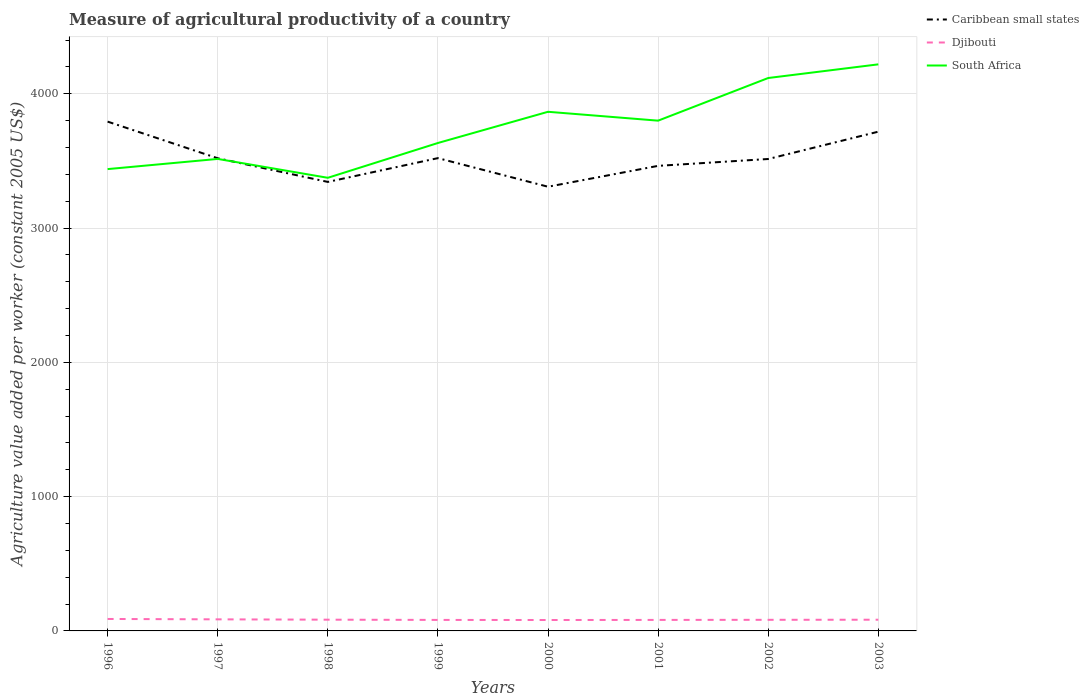How many different coloured lines are there?
Your answer should be compact. 3. Does the line corresponding to Caribbean small states intersect with the line corresponding to South Africa?
Your response must be concise. Yes. Is the number of lines equal to the number of legend labels?
Make the answer very short. Yes. Across all years, what is the maximum measure of agricultural productivity in Caribbean small states?
Ensure brevity in your answer.  3307.74. In which year was the measure of agricultural productivity in Caribbean small states maximum?
Your answer should be very brief. 2000. What is the total measure of agricultural productivity in Djibouti in the graph?
Give a very brief answer. 0.63. What is the difference between the highest and the second highest measure of agricultural productivity in Djibouti?
Your answer should be very brief. 7.74. What is the difference between the highest and the lowest measure of agricultural productivity in South Africa?
Provide a succinct answer. 4. How many lines are there?
Make the answer very short. 3. How many years are there in the graph?
Provide a succinct answer. 8. What is the difference between two consecutive major ticks on the Y-axis?
Provide a succinct answer. 1000. Are the values on the major ticks of Y-axis written in scientific E-notation?
Offer a terse response. No. Where does the legend appear in the graph?
Offer a very short reply. Top right. How many legend labels are there?
Offer a terse response. 3. What is the title of the graph?
Your answer should be compact. Measure of agricultural productivity of a country. Does "Burundi" appear as one of the legend labels in the graph?
Your response must be concise. No. What is the label or title of the X-axis?
Give a very brief answer. Years. What is the label or title of the Y-axis?
Provide a short and direct response. Agriculture value added per worker (constant 2005 US$). What is the Agriculture value added per worker (constant 2005 US$) in Caribbean small states in 1996?
Provide a short and direct response. 3792.64. What is the Agriculture value added per worker (constant 2005 US$) in Djibouti in 1996?
Provide a short and direct response. 89.04. What is the Agriculture value added per worker (constant 2005 US$) of South Africa in 1996?
Your answer should be compact. 3438.99. What is the Agriculture value added per worker (constant 2005 US$) in Caribbean small states in 1997?
Keep it short and to the point. 3519.77. What is the Agriculture value added per worker (constant 2005 US$) in Djibouti in 1997?
Keep it short and to the point. 86.22. What is the Agriculture value added per worker (constant 2005 US$) of South Africa in 1997?
Keep it short and to the point. 3514.77. What is the Agriculture value added per worker (constant 2005 US$) in Caribbean small states in 1998?
Provide a short and direct response. 3343.62. What is the Agriculture value added per worker (constant 2005 US$) of Djibouti in 1998?
Offer a very short reply. 83.72. What is the Agriculture value added per worker (constant 2005 US$) of South Africa in 1998?
Give a very brief answer. 3374.27. What is the Agriculture value added per worker (constant 2005 US$) of Caribbean small states in 1999?
Provide a succinct answer. 3520.71. What is the Agriculture value added per worker (constant 2005 US$) in Djibouti in 1999?
Keep it short and to the point. 81.93. What is the Agriculture value added per worker (constant 2005 US$) in South Africa in 1999?
Offer a very short reply. 3633.44. What is the Agriculture value added per worker (constant 2005 US$) in Caribbean small states in 2000?
Give a very brief answer. 3307.74. What is the Agriculture value added per worker (constant 2005 US$) of Djibouti in 2000?
Provide a succinct answer. 81.3. What is the Agriculture value added per worker (constant 2005 US$) in South Africa in 2000?
Your answer should be very brief. 3865.82. What is the Agriculture value added per worker (constant 2005 US$) of Caribbean small states in 2001?
Your response must be concise. 3463.22. What is the Agriculture value added per worker (constant 2005 US$) in Djibouti in 2001?
Offer a very short reply. 81.98. What is the Agriculture value added per worker (constant 2005 US$) in South Africa in 2001?
Your answer should be compact. 3799.78. What is the Agriculture value added per worker (constant 2005 US$) in Caribbean small states in 2002?
Ensure brevity in your answer.  3514.27. What is the Agriculture value added per worker (constant 2005 US$) in Djibouti in 2002?
Ensure brevity in your answer.  82.7. What is the Agriculture value added per worker (constant 2005 US$) of South Africa in 2002?
Your answer should be compact. 4117.37. What is the Agriculture value added per worker (constant 2005 US$) in Caribbean small states in 2003?
Ensure brevity in your answer.  3717.71. What is the Agriculture value added per worker (constant 2005 US$) of Djibouti in 2003?
Make the answer very short. 83.47. What is the Agriculture value added per worker (constant 2005 US$) of South Africa in 2003?
Make the answer very short. 4219.01. Across all years, what is the maximum Agriculture value added per worker (constant 2005 US$) of Caribbean small states?
Your response must be concise. 3792.64. Across all years, what is the maximum Agriculture value added per worker (constant 2005 US$) in Djibouti?
Keep it short and to the point. 89.04. Across all years, what is the maximum Agriculture value added per worker (constant 2005 US$) of South Africa?
Keep it short and to the point. 4219.01. Across all years, what is the minimum Agriculture value added per worker (constant 2005 US$) in Caribbean small states?
Provide a succinct answer. 3307.74. Across all years, what is the minimum Agriculture value added per worker (constant 2005 US$) in Djibouti?
Offer a very short reply. 81.3. Across all years, what is the minimum Agriculture value added per worker (constant 2005 US$) of South Africa?
Offer a terse response. 3374.27. What is the total Agriculture value added per worker (constant 2005 US$) of Caribbean small states in the graph?
Make the answer very short. 2.82e+04. What is the total Agriculture value added per worker (constant 2005 US$) of Djibouti in the graph?
Keep it short and to the point. 670.37. What is the total Agriculture value added per worker (constant 2005 US$) of South Africa in the graph?
Your answer should be compact. 3.00e+04. What is the difference between the Agriculture value added per worker (constant 2005 US$) in Caribbean small states in 1996 and that in 1997?
Ensure brevity in your answer.  272.87. What is the difference between the Agriculture value added per worker (constant 2005 US$) in Djibouti in 1996 and that in 1997?
Keep it short and to the point. 2.82. What is the difference between the Agriculture value added per worker (constant 2005 US$) in South Africa in 1996 and that in 1997?
Your answer should be very brief. -75.78. What is the difference between the Agriculture value added per worker (constant 2005 US$) in Caribbean small states in 1996 and that in 1998?
Your answer should be very brief. 449.02. What is the difference between the Agriculture value added per worker (constant 2005 US$) in Djibouti in 1996 and that in 1998?
Give a very brief answer. 5.32. What is the difference between the Agriculture value added per worker (constant 2005 US$) in South Africa in 1996 and that in 1998?
Offer a terse response. 64.73. What is the difference between the Agriculture value added per worker (constant 2005 US$) in Caribbean small states in 1996 and that in 1999?
Provide a short and direct response. 271.93. What is the difference between the Agriculture value added per worker (constant 2005 US$) in Djibouti in 1996 and that in 1999?
Your answer should be very brief. 7.11. What is the difference between the Agriculture value added per worker (constant 2005 US$) in South Africa in 1996 and that in 1999?
Offer a terse response. -194.45. What is the difference between the Agriculture value added per worker (constant 2005 US$) of Caribbean small states in 1996 and that in 2000?
Your answer should be compact. 484.9. What is the difference between the Agriculture value added per worker (constant 2005 US$) of Djibouti in 1996 and that in 2000?
Ensure brevity in your answer.  7.74. What is the difference between the Agriculture value added per worker (constant 2005 US$) of South Africa in 1996 and that in 2000?
Give a very brief answer. -426.83. What is the difference between the Agriculture value added per worker (constant 2005 US$) of Caribbean small states in 1996 and that in 2001?
Make the answer very short. 329.43. What is the difference between the Agriculture value added per worker (constant 2005 US$) of Djibouti in 1996 and that in 2001?
Offer a very short reply. 7.06. What is the difference between the Agriculture value added per worker (constant 2005 US$) of South Africa in 1996 and that in 2001?
Provide a short and direct response. -360.79. What is the difference between the Agriculture value added per worker (constant 2005 US$) in Caribbean small states in 1996 and that in 2002?
Your answer should be very brief. 278.37. What is the difference between the Agriculture value added per worker (constant 2005 US$) of Djibouti in 1996 and that in 2002?
Provide a short and direct response. 6.33. What is the difference between the Agriculture value added per worker (constant 2005 US$) in South Africa in 1996 and that in 2002?
Offer a very short reply. -678.37. What is the difference between the Agriculture value added per worker (constant 2005 US$) of Caribbean small states in 1996 and that in 2003?
Your answer should be very brief. 74.93. What is the difference between the Agriculture value added per worker (constant 2005 US$) of Djibouti in 1996 and that in 2003?
Keep it short and to the point. 5.57. What is the difference between the Agriculture value added per worker (constant 2005 US$) in South Africa in 1996 and that in 2003?
Make the answer very short. -780.02. What is the difference between the Agriculture value added per worker (constant 2005 US$) in Caribbean small states in 1997 and that in 1998?
Your answer should be compact. 176.15. What is the difference between the Agriculture value added per worker (constant 2005 US$) of Djibouti in 1997 and that in 1998?
Ensure brevity in your answer.  2.49. What is the difference between the Agriculture value added per worker (constant 2005 US$) in South Africa in 1997 and that in 1998?
Your answer should be very brief. 140.51. What is the difference between the Agriculture value added per worker (constant 2005 US$) in Caribbean small states in 1997 and that in 1999?
Your response must be concise. -0.94. What is the difference between the Agriculture value added per worker (constant 2005 US$) in Djibouti in 1997 and that in 1999?
Provide a short and direct response. 4.29. What is the difference between the Agriculture value added per worker (constant 2005 US$) in South Africa in 1997 and that in 1999?
Your answer should be very brief. -118.67. What is the difference between the Agriculture value added per worker (constant 2005 US$) in Caribbean small states in 1997 and that in 2000?
Offer a very short reply. 212.03. What is the difference between the Agriculture value added per worker (constant 2005 US$) in Djibouti in 1997 and that in 2000?
Your answer should be very brief. 4.91. What is the difference between the Agriculture value added per worker (constant 2005 US$) in South Africa in 1997 and that in 2000?
Your answer should be very brief. -351.04. What is the difference between the Agriculture value added per worker (constant 2005 US$) in Caribbean small states in 1997 and that in 2001?
Make the answer very short. 56.56. What is the difference between the Agriculture value added per worker (constant 2005 US$) in Djibouti in 1997 and that in 2001?
Offer a terse response. 4.23. What is the difference between the Agriculture value added per worker (constant 2005 US$) of South Africa in 1997 and that in 2001?
Your answer should be very brief. -285.01. What is the difference between the Agriculture value added per worker (constant 2005 US$) in Caribbean small states in 1997 and that in 2002?
Make the answer very short. 5.5. What is the difference between the Agriculture value added per worker (constant 2005 US$) in Djibouti in 1997 and that in 2002?
Offer a very short reply. 3.51. What is the difference between the Agriculture value added per worker (constant 2005 US$) in South Africa in 1997 and that in 2002?
Your answer should be very brief. -602.59. What is the difference between the Agriculture value added per worker (constant 2005 US$) in Caribbean small states in 1997 and that in 2003?
Your answer should be very brief. -197.94. What is the difference between the Agriculture value added per worker (constant 2005 US$) of Djibouti in 1997 and that in 2003?
Provide a succinct answer. 2.75. What is the difference between the Agriculture value added per worker (constant 2005 US$) of South Africa in 1997 and that in 2003?
Offer a terse response. -704.24. What is the difference between the Agriculture value added per worker (constant 2005 US$) in Caribbean small states in 1998 and that in 1999?
Your answer should be very brief. -177.09. What is the difference between the Agriculture value added per worker (constant 2005 US$) in Djibouti in 1998 and that in 1999?
Offer a very short reply. 1.79. What is the difference between the Agriculture value added per worker (constant 2005 US$) of South Africa in 1998 and that in 1999?
Keep it short and to the point. -259.17. What is the difference between the Agriculture value added per worker (constant 2005 US$) in Caribbean small states in 1998 and that in 2000?
Keep it short and to the point. 35.88. What is the difference between the Agriculture value added per worker (constant 2005 US$) of Djibouti in 1998 and that in 2000?
Provide a succinct answer. 2.42. What is the difference between the Agriculture value added per worker (constant 2005 US$) of South Africa in 1998 and that in 2000?
Make the answer very short. -491.55. What is the difference between the Agriculture value added per worker (constant 2005 US$) in Caribbean small states in 1998 and that in 2001?
Your answer should be very brief. -119.6. What is the difference between the Agriculture value added per worker (constant 2005 US$) in Djibouti in 1998 and that in 2001?
Keep it short and to the point. 1.74. What is the difference between the Agriculture value added per worker (constant 2005 US$) of South Africa in 1998 and that in 2001?
Ensure brevity in your answer.  -425.51. What is the difference between the Agriculture value added per worker (constant 2005 US$) in Caribbean small states in 1998 and that in 2002?
Offer a very short reply. -170.65. What is the difference between the Agriculture value added per worker (constant 2005 US$) in Djibouti in 1998 and that in 2002?
Provide a succinct answer. 1.02. What is the difference between the Agriculture value added per worker (constant 2005 US$) of South Africa in 1998 and that in 2002?
Give a very brief answer. -743.1. What is the difference between the Agriculture value added per worker (constant 2005 US$) in Caribbean small states in 1998 and that in 2003?
Offer a very short reply. -374.09. What is the difference between the Agriculture value added per worker (constant 2005 US$) of Djibouti in 1998 and that in 2003?
Provide a succinct answer. 0.25. What is the difference between the Agriculture value added per worker (constant 2005 US$) in South Africa in 1998 and that in 2003?
Offer a very short reply. -844.75. What is the difference between the Agriculture value added per worker (constant 2005 US$) of Caribbean small states in 1999 and that in 2000?
Offer a terse response. 212.97. What is the difference between the Agriculture value added per worker (constant 2005 US$) in Djibouti in 1999 and that in 2000?
Your response must be concise. 0.63. What is the difference between the Agriculture value added per worker (constant 2005 US$) in South Africa in 1999 and that in 2000?
Offer a very short reply. -232.38. What is the difference between the Agriculture value added per worker (constant 2005 US$) of Caribbean small states in 1999 and that in 2001?
Give a very brief answer. 57.5. What is the difference between the Agriculture value added per worker (constant 2005 US$) in Djibouti in 1999 and that in 2001?
Offer a terse response. -0.05. What is the difference between the Agriculture value added per worker (constant 2005 US$) of South Africa in 1999 and that in 2001?
Your answer should be compact. -166.34. What is the difference between the Agriculture value added per worker (constant 2005 US$) of Caribbean small states in 1999 and that in 2002?
Make the answer very short. 6.44. What is the difference between the Agriculture value added per worker (constant 2005 US$) of Djibouti in 1999 and that in 2002?
Make the answer very short. -0.77. What is the difference between the Agriculture value added per worker (constant 2005 US$) of South Africa in 1999 and that in 2002?
Your answer should be very brief. -483.93. What is the difference between the Agriculture value added per worker (constant 2005 US$) in Caribbean small states in 1999 and that in 2003?
Ensure brevity in your answer.  -197. What is the difference between the Agriculture value added per worker (constant 2005 US$) in Djibouti in 1999 and that in 2003?
Give a very brief answer. -1.54. What is the difference between the Agriculture value added per worker (constant 2005 US$) in South Africa in 1999 and that in 2003?
Your response must be concise. -585.57. What is the difference between the Agriculture value added per worker (constant 2005 US$) of Caribbean small states in 2000 and that in 2001?
Make the answer very short. -155.48. What is the difference between the Agriculture value added per worker (constant 2005 US$) of Djibouti in 2000 and that in 2001?
Keep it short and to the point. -0.68. What is the difference between the Agriculture value added per worker (constant 2005 US$) of South Africa in 2000 and that in 2001?
Offer a terse response. 66.04. What is the difference between the Agriculture value added per worker (constant 2005 US$) of Caribbean small states in 2000 and that in 2002?
Give a very brief answer. -206.53. What is the difference between the Agriculture value added per worker (constant 2005 US$) of Djibouti in 2000 and that in 2002?
Your response must be concise. -1.4. What is the difference between the Agriculture value added per worker (constant 2005 US$) in South Africa in 2000 and that in 2002?
Your answer should be very brief. -251.55. What is the difference between the Agriculture value added per worker (constant 2005 US$) of Caribbean small states in 2000 and that in 2003?
Offer a very short reply. -409.97. What is the difference between the Agriculture value added per worker (constant 2005 US$) of Djibouti in 2000 and that in 2003?
Ensure brevity in your answer.  -2.17. What is the difference between the Agriculture value added per worker (constant 2005 US$) of South Africa in 2000 and that in 2003?
Give a very brief answer. -353.19. What is the difference between the Agriculture value added per worker (constant 2005 US$) of Caribbean small states in 2001 and that in 2002?
Provide a succinct answer. -51.06. What is the difference between the Agriculture value added per worker (constant 2005 US$) of Djibouti in 2001 and that in 2002?
Your answer should be very brief. -0.72. What is the difference between the Agriculture value added per worker (constant 2005 US$) in South Africa in 2001 and that in 2002?
Give a very brief answer. -317.59. What is the difference between the Agriculture value added per worker (constant 2005 US$) of Caribbean small states in 2001 and that in 2003?
Provide a short and direct response. -254.49. What is the difference between the Agriculture value added per worker (constant 2005 US$) of Djibouti in 2001 and that in 2003?
Your response must be concise. -1.49. What is the difference between the Agriculture value added per worker (constant 2005 US$) in South Africa in 2001 and that in 2003?
Make the answer very short. -419.23. What is the difference between the Agriculture value added per worker (constant 2005 US$) in Caribbean small states in 2002 and that in 2003?
Make the answer very short. -203.44. What is the difference between the Agriculture value added per worker (constant 2005 US$) of Djibouti in 2002 and that in 2003?
Ensure brevity in your answer.  -0.77. What is the difference between the Agriculture value added per worker (constant 2005 US$) of South Africa in 2002 and that in 2003?
Keep it short and to the point. -101.65. What is the difference between the Agriculture value added per worker (constant 2005 US$) in Caribbean small states in 1996 and the Agriculture value added per worker (constant 2005 US$) in Djibouti in 1997?
Provide a short and direct response. 3706.43. What is the difference between the Agriculture value added per worker (constant 2005 US$) of Caribbean small states in 1996 and the Agriculture value added per worker (constant 2005 US$) of South Africa in 1997?
Ensure brevity in your answer.  277.87. What is the difference between the Agriculture value added per worker (constant 2005 US$) in Djibouti in 1996 and the Agriculture value added per worker (constant 2005 US$) in South Africa in 1997?
Your answer should be very brief. -3425.74. What is the difference between the Agriculture value added per worker (constant 2005 US$) in Caribbean small states in 1996 and the Agriculture value added per worker (constant 2005 US$) in Djibouti in 1998?
Ensure brevity in your answer.  3708.92. What is the difference between the Agriculture value added per worker (constant 2005 US$) of Caribbean small states in 1996 and the Agriculture value added per worker (constant 2005 US$) of South Africa in 1998?
Offer a very short reply. 418.38. What is the difference between the Agriculture value added per worker (constant 2005 US$) of Djibouti in 1996 and the Agriculture value added per worker (constant 2005 US$) of South Africa in 1998?
Your response must be concise. -3285.23. What is the difference between the Agriculture value added per worker (constant 2005 US$) in Caribbean small states in 1996 and the Agriculture value added per worker (constant 2005 US$) in Djibouti in 1999?
Your answer should be compact. 3710.71. What is the difference between the Agriculture value added per worker (constant 2005 US$) in Caribbean small states in 1996 and the Agriculture value added per worker (constant 2005 US$) in South Africa in 1999?
Your response must be concise. 159.2. What is the difference between the Agriculture value added per worker (constant 2005 US$) of Djibouti in 1996 and the Agriculture value added per worker (constant 2005 US$) of South Africa in 1999?
Ensure brevity in your answer.  -3544.4. What is the difference between the Agriculture value added per worker (constant 2005 US$) of Caribbean small states in 1996 and the Agriculture value added per worker (constant 2005 US$) of Djibouti in 2000?
Offer a terse response. 3711.34. What is the difference between the Agriculture value added per worker (constant 2005 US$) of Caribbean small states in 1996 and the Agriculture value added per worker (constant 2005 US$) of South Africa in 2000?
Give a very brief answer. -73.17. What is the difference between the Agriculture value added per worker (constant 2005 US$) in Djibouti in 1996 and the Agriculture value added per worker (constant 2005 US$) in South Africa in 2000?
Provide a short and direct response. -3776.78. What is the difference between the Agriculture value added per worker (constant 2005 US$) in Caribbean small states in 1996 and the Agriculture value added per worker (constant 2005 US$) in Djibouti in 2001?
Your response must be concise. 3710.66. What is the difference between the Agriculture value added per worker (constant 2005 US$) in Caribbean small states in 1996 and the Agriculture value added per worker (constant 2005 US$) in South Africa in 2001?
Keep it short and to the point. -7.14. What is the difference between the Agriculture value added per worker (constant 2005 US$) in Djibouti in 1996 and the Agriculture value added per worker (constant 2005 US$) in South Africa in 2001?
Make the answer very short. -3710.74. What is the difference between the Agriculture value added per worker (constant 2005 US$) of Caribbean small states in 1996 and the Agriculture value added per worker (constant 2005 US$) of Djibouti in 2002?
Offer a very short reply. 3709.94. What is the difference between the Agriculture value added per worker (constant 2005 US$) of Caribbean small states in 1996 and the Agriculture value added per worker (constant 2005 US$) of South Africa in 2002?
Make the answer very short. -324.72. What is the difference between the Agriculture value added per worker (constant 2005 US$) of Djibouti in 1996 and the Agriculture value added per worker (constant 2005 US$) of South Africa in 2002?
Offer a very short reply. -4028.33. What is the difference between the Agriculture value added per worker (constant 2005 US$) of Caribbean small states in 1996 and the Agriculture value added per worker (constant 2005 US$) of Djibouti in 2003?
Make the answer very short. 3709.17. What is the difference between the Agriculture value added per worker (constant 2005 US$) of Caribbean small states in 1996 and the Agriculture value added per worker (constant 2005 US$) of South Africa in 2003?
Ensure brevity in your answer.  -426.37. What is the difference between the Agriculture value added per worker (constant 2005 US$) of Djibouti in 1996 and the Agriculture value added per worker (constant 2005 US$) of South Africa in 2003?
Your answer should be compact. -4129.97. What is the difference between the Agriculture value added per worker (constant 2005 US$) in Caribbean small states in 1997 and the Agriculture value added per worker (constant 2005 US$) in Djibouti in 1998?
Your answer should be very brief. 3436.05. What is the difference between the Agriculture value added per worker (constant 2005 US$) of Caribbean small states in 1997 and the Agriculture value added per worker (constant 2005 US$) of South Africa in 1998?
Provide a short and direct response. 145.51. What is the difference between the Agriculture value added per worker (constant 2005 US$) of Djibouti in 1997 and the Agriculture value added per worker (constant 2005 US$) of South Africa in 1998?
Offer a very short reply. -3288.05. What is the difference between the Agriculture value added per worker (constant 2005 US$) in Caribbean small states in 1997 and the Agriculture value added per worker (constant 2005 US$) in Djibouti in 1999?
Your answer should be very brief. 3437.84. What is the difference between the Agriculture value added per worker (constant 2005 US$) of Caribbean small states in 1997 and the Agriculture value added per worker (constant 2005 US$) of South Africa in 1999?
Make the answer very short. -113.67. What is the difference between the Agriculture value added per worker (constant 2005 US$) of Djibouti in 1997 and the Agriculture value added per worker (constant 2005 US$) of South Africa in 1999?
Keep it short and to the point. -3547.22. What is the difference between the Agriculture value added per worker (constant 2005 US$) in Caribbean small states in 1997 and the Agriculture value added per worker (constant 2005 US$) in Djibouti in 2000?
Provide a succinct answer. 3438.47. What is the difference between the Agriculture value added per worker (constant 2005 US$) in Caribbean small states in 1997 and the Agriculture value added per worker (constant 2005 US$) in South Africa in 2000?
Make the answer very short. -346.05. What is the difference between the Agriculture value added per worker (constant 2005 US$) of Djibouti in 1997 and the Agriculture value added per worker (constant 2005 US$) of South Africa in 2000?
Provide a succinct answer. -3779.6. What is the difference between the Agriculture value added per worker (constant 2005 US$) of Caribbean small states in 1997 and the Agriculture value added per worker (constant 2005 US$) of Djibouti in 2001?
Make the answer very short. 3437.79. What is the difference between the Agriculture value added per worker (constant 2005 US$) of Caribbean small states in 1997 and the Agriculture value added per worker (constant 2005 US$) of South Africa in 2001?
Make the answer very short. -280.01. What is the difference between the Agriculture value added per worker (constant 2005 US$) of Djibouti in 1997 and the Agriculture value added per worker (constant 2005 US$) of South Africa in 2001?
Make the answer very short. -3713.56. What is the difference between the Agriculture value added per worker (constant 2005 US$) of Caribbean small states in 1997 and the Agriculture value added per worker (constant 2005 US$) of Djibouti in 2002?
Offer a terse response. 3437.07. What is the difference between the Agriculture value added per worker (constant 2005 US$) in Caribbean small states in 1997 and the Agriculture value added per worker (constant 2005 US$) in South Africa in 2002?
Your answer should be very brief. -597.59. What is the difference between the Agriculture value added per worker (constant 2005 US$) of Djibouti in 1997 and the Agriculture value added per worker (constant 2005 US$) of South Africa in 2002?
Provide a succinct answer. -4031.15. What is the difference between the Agriculture value added per worker (constant 2005 US$) of Caribbean small states in 1997 and the Agriculture value added per worker (constant 2005 US$) of Djibouti in 2003?
Keep it short and to the point. 3436.3. What is the difference between the Agriculture value added per worker (constant 2005 US$) in Caribbean small states in 1997 and the Agriculture value added per worker (constant 2005 US$) in South Africa in 2003?
Provide a succinct answer. -699.24. What is the difference between the Agriculture value added per worker (constant 2005 US$) of Djibouti in 1997 and the Agriculture value added per worker (constant 2005 US$) of South Africa in 2003?
Your answer should be very brief. -4132.8. What is the difference between the Agriculture value added per worker (constant 2005 US$) in Caribbean small states in 1998 and the Agriculture value added per worker (constant 2005 US$) in Djibouti in 1999?
Offer a terse response. 3261.69. What is the difference between the Agriculture value added per worker (constant 2005 US$) in Caribbean small states in 1998 and the Agriculture value added per worker (constant 2005 US$) in South Africa in 1999?
Your answer should be very brief. -289.82. What is the difference between the Agriculture value added per worker (constant 2005 US$) of Djibouti in 1998 and the Agriculture value added per worker (constant 2005 US$) of South Africa in 1999?
Make the answer very short. -3549.72. What is the difference between the Agriculture value added per worker (constant 2005 US$) of Caribbean small states in 1998 and the Agriculture value added per worker (constant 2005 US$) of Djibouti in 2000?
Provide a succinct answer. 3262.32. What is the difference between the Agriculture value added per worker (constant 2005 US$) of Caribbean small states in 1998 and the Agriculture value added per worker (constant 2005 US$) of South Africa in 2000?
Give a very brief answer. -522.2. What is the difference between the Agriculture value added per worker (constant 2005 US$) of Djibouti in 1998 and the Agriculture value added per worker (constant 2005 US$) of South Africa in 2000?
Provide a short and direct response. -3782.1. What is the difference between the Agriculture value added per worker (constant 2005 US$) of Caribbean small states in 1998 and the Agriculture value added per worker (constant 2005 US$) of Djibouti in 2001?
Provide a short and direct response. 3261.64. What is the difference between the Agriculture value added per worker (constant 2005 US$) of Caribbean small states in 1998 and the Agriculture value added per worker (constant 2005 US$) of South Africa in 2001?
Make the answer very short. -456.16. What is the difference between the Agriculture value added per worker (constant 2005 US$) in Djibouti in 1998 and the Agriculture value added per worker (constant 2005 US$) in South Africa in 2001?
Offer a very short reply. -3716.06. What is the difference between the Agriculture value added per worker (constant 2005 US$) in Caribbean small states in 1998 and the Agriculture value added per worker (constant 2005 US$) in Djibouti in 2002?
Keep it short and to the point. 3260.92. What is the difference between the Agriculture value added per worker (constant 2005 US$) in Caribbean small states in 1998 and the Agriculture value added per worker (constant 2005 US$) in South Africa in 2002?
Provide a short and direct response. -773.75. What is the difference between the Agriculture value added per worker (constant 2005 US$) of Djibouti in 1998 and the Agriculture value added per worker (constant 2005 US$) of South Africa in 2002?
Provide a short and direct response. -4033.64. What is the difference between the Agriculture value added per worker (constant 2005 US$) of Caribbean small states in 1998 and the Agriculture value added per worker (constant 2005 US$) of Djibouti in 2003?
Keep it short and to the point. 3260.15. What is the difference between the Agriculture value added per worker (constant 2005 US$) of Caribbean small states in 1998 and the Agriculture value added per worker (constant 2005 US$) of South Africa in 2003?
Your answer should be very brief. -875.39. What is the difference between the Agriculture value added per worker (constant 2005 US$) in Djibouti in 1998 and the Agriculture value added per worker (constant 2005 US$) in South Africa in 2003?
Offer a very short reply. -4135.29. What is the difference between the Agriculture value added per worker (constant 2005 US$) of Caribbean small states in 1999 and the Agriculture value added per worker (constant 2005 US$) of Djibouti in 2000?
Give a very brief answer. 3439.41. What is the difference between the Agriculture value added per worker (constant 2005 US$) of Caribbean small states in 1999 and the Agriculture value added per worker (constant 2005 US$) of South Africa in 2000?
Offer a very short reply. -345.1. What is the difference between the Agriculture value added per worker (constant 2005 US$) in Djibouti in 1999 and the Agriculture value added per worker (constant 2005 US$) in South Africa in 2000?
Your response must be concise. -3783.89. What is the difference between the Agriculture value added per worker (constant 2005 US$) of Caribbean small states in 1999 and the Agriculture value added per worker (constant 2005 US$) of Djibouti in 2001?
Provide a succinct answer. 3438.73. What is the difference between the Agriculture value added per worker (constant 2005 US$) in Caribbean small states in 1999 and the Agriculture value added per worker (constant 2005 US$) in South Africa in 2001?
Keep it short and to the point. -279.07. What is the difference between the Agriculture value added per worker (constant 2005 US$) of Djibouti in 1999 and the Agriculture value added per worker (constant 2005 US$) of South Africa in 2001?
Offer a terse response. -3717.85. What is the difference between the Agriculture value added per worker (constant 2005 US$) in Caribbean small states in 1999 and the Agriculture value added per worker (constant 2005 US$) in Djibouti in 2002?
Provide a short and direct response. 3438.01. What is the difference between the Agriculture value added per worker (constant 2005 US$) in Caribbean small states in 1999 and the Agriculture value added per worker (constant 2005 US$) in South Africa in 2002?
Your response must be concise. -596.65. What is the difference between the Agriculture value added per worker (constant 2005 US$) in Djibouti in 1999 and the Agriculture value added per worker (constant 2005 US$) in South Africa in 2002?
Give a very brief answer. -4035.44. What is the difference between the Agriculture value added per worker (constant 2005 US$) of Caribbean small states in 1999 and the Agriculture value added per worker (constant 2005 US$) of Djibouti in 2003?
Your answer should be very brief. 3437.24. What is the difference between the Agriculture value added per worker (constant 2005 US$) in Caribbean small states in 1999 and the Agriculture value added per worker (constant 2005 US$) in South Africa in 2003?
Give a very brief answer. -698.3. What is the difference between the Agriculture value added per worker (constant 2005 US$) in Djibouti in 1999 and the Agriculture value added per worker (constant 2005 US$) in South Africa in 2003?
Your response must be concise. -4137.08. What is the difference between the Agriculture value added per worker (constant 2005 US$) in Caribbean small states in 2000 and the Agriculture value added per worker (constant 2005 US$) in Djibouti in 2001?
Your response must be concise. 3225.76. What is the difference between the Agriculture value added per worker (constant 2005 US$) in Caribbean small states in 2000 and the Agriculture value added per worker (constant 2005 US$) in South Africa in 2001?
Your answer should be compact. -492.04. What is the difference between the Agriculture value added per worker (constant 2005 US$) in Djibouti in 2000 and the Agriculture value added per worker (constant 2005 US$) in South Africa in 2001?
Offer a terse response. -3718.48. What is the difference between the Agriculture value added per worker (constant 2005 US$) in Caribbean small states in 2000 and the Agriculture value added per worker (constant 2005 US$) in Djibouti in 2002?
Give a very brief answer. 3225.04. What is the difference between the Agriculture value added per worker (constant 2005 US$) of Caribbean small states in 2000 and the Agriculture value added per worker (constant 2005 US$) of South Africa in 2002?
Offer a terse response. -809.62. What is the difference between the Agriculture value added per worker (constant 2005 US$) in Djibouti in 2000 and the Agriculture value added per worker (constant 2005 US$) in South Africa in 2002?
Provide a short and direct response. -4036.06. What is the difference between the Agriculture value added per worker (constant 2005 US$) in Caribbean small states in 2000 and the Agriculture value added per worker (constant 2005 US$) in Djibouti in 2003?
Offer a terse response. 3224.27. What is the difference between the Agriculture value added per worker (constant 2005 US$) in Caribbean small states in 2000 and the Agriculture value added per worker (constant 2005 US$) in South Africa in 2003?
Provide a succinct answer. -911.27. What is the difference between the Agriculture value added per worker (constant 2005 US$) of Djibouti in 2000 and the Agriculture value added per worker (constant 2005 US$) of South Africa in 2003?
Make the answer very short. -4137.71. What is the difference between the Agriculture value added per worker (constant 2005 US$) of Caribbean small states in 2001 and the Agriculture value added per worker (constant 2005 US$) of Djibouti in 2002?
Your answer should be compact. 3380.51. What is the difference between the Agriculture value added per worker (constant 2005 US$) in Caribbean small states in 2001 and the Agriculture value added per worker (constant 2005 US$) in South Africa in 2002?
Your answer should be very brief. -654.15. What is the difference between the Agriculture value added per worker (constant 2005 US$) of Djibouti in 2001 and the Agriculture value added per worker (constant 2005 US$) of South Africa in 2002?
Offer a terse response. -4035.38. What is the difference between the Agriculture value added per worker (constant 2005 US$) of Caribbean small states in 2001 and the Agriculture value added per worker (constant 2005 US$) of Djibouti in 2003?
Your response must be concise. 3379.75. What is the difference between the Agriculture value added per worker (constant 2005 US$) in Caribbean small states in 2001 and the Agriculture value added per worker (constant 2005 US$) in South Africa in 2003?
Give a very brief answer. -755.8. What is the difference between the Agriculture value added per worker (constant 2005 US$) of Djibouti in 2001 and the Agriculture value added per worker (constant 2005 US$) of South Africa in 2003?
Your answer should be very brief. -4137.03. What is the difference between the Agriculture value added per worker (constant 2005 US$) in Caribbean small states in 2002 and the Agriculture value added per worker (constant 2005 US$) in Djibouti in 2003?
Ensure brevity in your answer.  3430.8. What is the difference between the Agriculture value added per worker (constant 2005 US$) of Caribbean small states in 2002 and the Agriculture value added per worker (constant 2005 US$) of South Africa in 2003?
Offer a very short reply. -704.74. What is the difference between the Agriculture value added per worker (constant 2005 US$) of Djibouti in 2002 and the Agriculture value added per worker (constant 2005 US$) of South Africa in 2003?
Your answer should be very brief. -4136.31. What is the average Agriculture value added per worker (constant 2005 US$) of Caribbean small states per year?
Make the answer very short. 3522.46. What is the average Agriculture value added per worker (constant 2005 US$) in Djibouti per year?
Keep it short and to the point. 83.8. What is the average Agriculture value added per worker (constant 2005 US$) of South Africa per year?
Give a very brief answer. 3745.43. In the year 1996, what is the difference between the Agriculture value added per worker (constant 2005 US$) in Caribbean small states and Agriculture value added per worker (constant 2005 US$) in Djibouti?
Ensure brevity in your answer.  3703.61. In the year 1996, what is the difference between the Agriculture value added per worker (constant 2005 US$) of Caribbean small states and Agriculture value added per worker (constant 2005 US$) of South Africa?
Your response must be concise. 353.65. In the year 1996, what is the difference between the Agriculture value added per worker (constant 2005 US$) of Djibouti and Agriculture value added per worker (constant 2005 US$) of South Africa?
Offer a very short reply. -3349.95. In the year 1997, what is the difference between the Agriculture value added per worker (constant 2005 US$) in Caribbean small states and Agriculture value added per worker (constant 2005 US$) in Djibouti?
Offer a very short reply. 3433.56. In the year 1997, what is the difference between the Agriculture value added per worker (constant 2005 US$) of Caribbean small states and Agriculture value added per worker (constant 2005 US$) of South Africa?
Ensure brevity in your answer.  5. In the year 1997, what is the difference between the Agriculture value added per worker (constant 2005 US$) of Djibouti and Agriculture value added per worker (constant 2005 US$) of South Africa?
Your answer should be compact. -3428.56. In the year 1998, what is the difference between the Agriculture value added per worker (constant 2005 US$) of Caribbean small states and Agriculture value added per worker (constant 2005 US$) of Djibouti?
Your answer should be compact. 3259.9. In the year 1998, what is the difference between the Agriculture value added per worker (constant 2005 US$) in Caribbean small states and Agriculture value added per worker (constant 2005 US$) in South Africa?
Provide a short and direct response. -30.65. In the year 1998, what is the difference between the Agriculture value added per worker (constant 2005 US$) in Djibouti and Agriculture value added per worker (constant 2005 US$) in South Africa?
Provide a succinct answer. -3290.54. In the year 1999, what is the difference between the Agriculture value added per worker (constant 2005 US$) of Caribbean small states and Agriculture value added per worker (constant 2005 US$) of Djibouti?
Keep it short and to the point. 3438.78. In the year 1999, what is the difference between the Agriculture value added per worker (constant 2005 US$) of Caribbean small states and Agriculture value added per worker (constant 2005 US$) of South Africa?
Your answer should be very brief. -112.73. In the year 1999, what is the difference between the Agriculture value added per worker (constant 2005 US$) in Djibouti and Agriculture value added per worker (constant 2005 US$) in South Africa?
Provide a short and direct response. -3551.51. In the year 2000, what is the difference between the Agriculture value added per worker (constant 2005 US$) of Caribbean small states and Agriculture value added per worker (constant 2005 US$) of Djibouti?
Provide a succinct answer. 3226.44. In the year 2000, what is the difference between the Agriculture value added per worker (constant 2005 US$) in Caribbean small states and Agriculture value added per worker (constant 2005 US$) in South Africa?
Give a very brief answer. -558.08. In the year 2000, what is the difference between the Agriculture value added per worker (constant 2005 US$) in Djibouti and Agriculture value added per worker (constant 2005 US$) in South Africa?
Keep it short and to the point. -3784.52. In the year 2001, what is the difference between the Agriculture value added per worker (constant 2005 US$) of Caribbean small states and Agriculture value added per worker (constant 2005 US$) of Djibouti?
Your response must be concise. 3381.24. In the year 2001, what is the difference between the Agriculture value added per worker (constant 2005 US$) in Caribbean small states and Agriculture value added per worker (constant 2005 US$) in South Africa?
Give a very brief answer. -336.56. In the year 2001, what is the difference between the Agriculture value added per worker (constant 2005 US$) of Djibouti and Agriculture value added per worker (constant 2005 US$) of South Africa?
Provide a succinct answer. -3717.8. In the year 2002, what is the difference between the Agriculture value added per worker (constant 2005 US$) in Caribbean small states and Agriculture value added per worker (constant 2005 US$) in Djibouti?
Offer a very short reply. 3431.57. In the year 2002, what is the difference between the Agriculture value added per worker (constant 2005 US$) of Caribbean small states and Agriculture value added per worker (constant 2005 US$) of South Africa?
Give a very brief answer. -603.09. In the year 2002, what is the difference between the Agriculture value added per worker (constant 2005 US$) in Djibouti and Agriculture value added per worker (constant 2005 US$) in South Africa?
Give a very brief answer. -4034.66. In the year 2003, what is the difference between the Agriculture value added per worker (constant 2005 US$) of Caribbean small states and Agriculture value added per worker (constant 2005 US$) of Djibouti?
Your answer should be compact. 3634.24. In the year 2003, what is the difference between the Agriculture value added per worker (constant 2005 US$) in Caribbean small states and Agriculture value added per worker (constant 2005 US$) in South Africa?
Keep it short and to the point. -501.3. In the year 2003, what is the difference between the Agriculture value added per worker (constant 2005 US$) in Djibouti and Agriculture value added per worker (constant 2005 US$) in South Africa?
Your answer should be compact. -4135.54. What is the ratio of the Agriculture value added per worker (constant 2005 US$) in Caribbean small states in 1996 to that in 1997?
Your answer should be very brief. 1.08. What is the ratio of the Agriculture value added per worker (constant 2005 US$) in Djibouti in 1996 to that in 1997?
Your answer should be very brief. 1.03. What is the ratio of the Agriculture value added per worker (constant 2005 US$) in South Africa in 1996 to that in 1997?
Your response must be concise. 0.98. What is the ratio of the Agriculture value added per worker (constant 2005 US$) of Caribbean small states in 1996 to that in 1998?
Your response must be concise. 1.13. What is the ratio of the Agriculture value added per worker (constant 2005 US$) of Djibouti in 1996 to that in 1998?
Keep it short and to the point. 1.06. What is the ratio of the Agriculture value added per worker (constant 2005 US$) in South Africa in 1996 to that in 1998?
Ensure brevity in your answer.  1.02. What is the ratio of the Agriculture value added per worker (constant 2005 US$) of Caribbean small states in 1996 to that in 1999?
Provide a succinct answer. 1.08. What is the ratio of the Agriculture value added per worker (constant 2005 US$) of Djibouti in 1996 to that in 1999?
Give a very brief answer. 1.09. What is the ratio of the Agriculture value added per worker (constant 2005 US$) in South Africa in 1996 to that in 1999?
Your answer should be compact. 0.95. What is the ratio of the Agriculture value added per worker (constant 2005 US$) of Caribbean small states in 1996 to that in 2000?
Your answer should be very brief. 1.15. What is the ratio of the Agriculture value added per worker (constant 2005 US$) in Djibouti in 1996 to that in 2000?
Your answer should be very brief. 1.1. What is the ratio of the Agriculture value added per worker (constant 2005 US$) in South Africa in 1996 to that in 2000?
Keep it short and to the point. 0.89. What is the ratio of the Agriculture value added per worker (constant 2005 US$) of Caribbean small states in 1996 to that in 2001?
Your answer should be very brief. 1.1. What is the ratio of the Agriculture value added per worker (constant 2005 US$) of Djibouti in 1996 to that in 2001?
Give a very brief answer. 1.09. What is the ratio of the Agriculture value added per worker (constant 2005 US$) in South Africa in 1996 to that in 2001?
Keep it short and to the point. 0.91. What is the ratio of the Agriculture value added per worker (constant 2005 US$) of Caribbean small states in 1996 to that in 2002?
Provide a succinct answer. 1.08. What is the ratio of the Agriculture value added per worker (constant 2005 US$) in Djibouti in 1996 to that in 2002?
Ensure brevity in your answer.  1.08. What is the ratio of the Agriculture value added per worker (constant 2005 US$) in South Africa in 1996 to that in 2002?
Make the answer very short. 0.84. What is the ratio of the Agriculture value added per worker (constant 2005 US$) in Caribbean small states in 1996 to that in 2003?
Offer a very short reply. 1.02. What is the ratio of the Agriculture value added per worker (constant 2005 US$) in Djibouti in 1996 to that in 2003?
Your answer should be very brief. 1.07. What is the ratio of the Agriculture value added per worker (constant 2005 US$) in South Africa in 1996 to that in 2003?
Your response must be concise. 0.82. What is the ratio of the Agriculture value added per worker (constant 2005 US$) in Caribbean small states in 1997 to that in 1998?
Your answer should be compact. 1.05. What is the ratio of the Agriculture value added per worker (constant 2005 US$) of Djibouti in 1997 to that in 1998?
Ensure brevity in your answer.  1.03. What is the ratio of the Agriculture value added per worker (constant 2005 US$) in South Africa in 1997 to that in 1998?
Ensure brevity in your answer.  1.04. What is the ratio of the Agriculture value added per worker (constant 2005 US$) of Caribbean small states in 1997 to that in 1999?
Your answer should be compact. 1. What is the ratio of the Agriculture value added per worker (constant 2005 US$) of Djibouti in 1997 to that in 1999?
Make the answer very short. 1.05. What is the ratio of the Agriculture value added per worker (constant 2005 US$) of South Africa in 1997 to that in 1999?
Your response must be concise. 0.97. What is the ratio of the Agriculture value added per worker (constant 2005 US$) in Caribbean small states in 1997 to that in 2000?
Provide a succinct answer. 1.06. What is the ratio of the Agriculture value added per worker (constant 2005 US$) of Djibouti in 1997 to that in 2000?
Your response must be concise. 1.06. What is the ratio of the Agriculture value added per worker (constant 2005 US$) of South Africa in 1997 to that in 2000?
Your response must be concise. 0.91. What is the ratio of the Agriculture value added per worker (constant 2005 US$) of Caribbean small states in 1997 to that in 2001?
Give a very brief answer. 1.02. What is the ratio of the Agriculture value added per worker (constant 2005 US$) in Djibouti in 1997 to that in 2001?
Offer a terse response. 1.05. What is the ratio of the Agriculture value added per worker (constant 2005 US$) in South Africa in 1997 to that in 2001?
Offer a terse response. 0.93. What is the ratio of the Agriculture value added per worker (constant 2005 US$) of Djibouti in 1997 to that in 2002?
Make the answer very short. 1.04. What is the ratio of the Agriculture value added per worker (constant 2005 US$) of South Africa in 1997 to that in 2002?
Make the answer very short. 0.85. What is the ratio of the Agriculture value added per worker (constant 2005 US$) in Caribbean small states in 1997 to that in 2003?
Provide a short and direct response. 0.95. What is the ratio of the Agriculture value added per worker (constant 2005 US$) in Djibouti in 1997 to that in 2003?
Make the answer very short. 1.03. What is the ratio of the Agriculture value added per worker (constant 2005 US$) of South Africa in 1997 to that in 2003?
Provide a succinct answer. 0.83. What is the ratio of the Agriculture value added per worker (constant 2005 US$) in Caribbean small states in 1998 to that in 1999?
Give a very brief answer. 0.95. What is the ratio of the Agriculture value added per worker (constant 2005 US$) in Djibouti in 1998 to that in 1999?
Your answer should be very brief. 1.02. What is the ratio of the Agriculture value added per worker (constant 2005 US$) of South Africa in 1998 to that in 1999?
Ensure brevity in your answer.  0.93. What is the ratio of the Agriculture value added per worker (constant 2005 US$) in Caribbean small states in 1998 to that in 2000?
Offer a very short reply. 1.01. What is the ratio of the Agriculture value added per worker (constant 2005 US$) of Djibouti in 1998 to that in 2000?
Offer a very short reply. 1.03. What is the ratio of the Agriculture value added per worker (constant 2005 US$) in South Africa in 1998 to that in 2000?
Keep it short and to the point. 0.87. What is the ratio of the Agriculture value added per worker (constant 2005 US$) of Caribbean small states in 1998 to that in 2001?
Give a very brief answer. 0.97. What is the ratio of the Agriculture value added per worker (constant 2005 US$) in Djibouti in 1998 to that in 2001?
Offer a terse response. 1.02. What is the ratio of the Agriculture value added per worker (constant 2005 US$) of South Africa in 1998 to that in 2001?
Ensure brevity in your answer.  0.89. What is the ratio of the Agriculture value added per worker (constant 2005 US$) in Caribbean small states in 1998 to that in 2002?
Your answer should be very brief. 0.95. What is the ratio of the Agriculture value added per worker (constant 2005 US$) of Djibouti in 1998 to that in 2002?
Give a very brief answer. 1.01. What is the ratio of the Agriculture value added per worker (constant 2005 US$) of South Africa in 1998 to that in 2002?
Your answer should be very brief. 0.82. What is the ratio of the Agriculture value added per worker (constant 2005 US$) in Caribbean small states in 1998 to that in 2003?
Give a very brief answer. 0.9. What is the ratio of the Agriculture value added per worker (constant 2005 US$) of South Africa in 1998 to that in 2003?
Provide a short and direct response. 0.8. What is the ratio of the Agriculture value added per worker (constant 2005 US$) in Caribbean small states in 1999 to that in 2000?
Make the answer very short. 1.06. What is the ratio of the Agriculture value added per worker (constant 2005 US$) of Djibouti in 1999 to that in 2000?
Your answer should be very brief. 1.01. What is the ratio of the Agriculture value added per worker (constant 2005 US$) in South Africa in 1999 to that in 2000?
Provide a short and direct response. 0.94. What is the ratio of the Agriculture value added per worker (constant 2005 US$) in Caribbean small states in 1999 to that in 2001?
Offer a terse response. 1.02. What is the ratio of the Agriculture value added per worker (constant 2005 US$) in South Africa in 1999 to that in 2001?
Make the answer very short. 0.96. What is the ratio of the Agriculture value added per worker (constant 2005 US$) in Caribbean small states in 1999 to that in 2002?
Your answer should be compact. 1. What is the ratio of the Agriculture value added per worker (constant 2005 US$) of Djibouti in 1999 to that in 2002?
Your answer should be compact. 0.99. What is the ratio of the Agriculture value added per worker (constant 2005 US$) of South Africa in 1999 to that in 2002?
Make the answer very short. 0.88. What is the ratio of the Agriculture value added per worker (constant 2005 US$) in Caribbean small states in 1999 to that in 2003?
Give a very brief answer. 0.95. What is the ratio of the Agriculture value added per worker (constant 2005 US$) in Djibouti in 1999 to that in 2003?
Your answer should be compact. 0.98. What is the ratio of the Agriculture value added per worker (constant 2005 US$) of South Africa in 1999 to that in 2003?
Provide a short and direct response. 0.86. What is the ratio of the Agriculture value added per worker (constant 2005 US$) in Caribbean small states in 2000 to that in 2001?
Make the answer very short. 0.96. What is the ratio of the Agriculture value added per worker (constant 2005 US$) in Djibouti in 2000 to that in 2001?
Offer a very short reply. 0.99. What is the ratio of the Agriculture value added per worker (constant 2005 US$) of South Africa in 2000 to that in 2001?
Provide a succinct answer. 1.02. What is the ratio of the Agriculture value added per worker (constant 2005 US$) of Djibouti in 2000 to that in 2002?
Provide a succinct answer. 0.98. What is the ratio of the Agriculture value added per worker (constant 2005 US$) of South Africa in 2000 to that in 2002?
Your answer should be compact. 0.94. What is the ratio of the Agriculture value added per worker (constant 2005 US$) in Caribbean small states in 2000 to that in 2003?
Keep it short and to the point. 0.89. What is the ratio of the Agriculture value added per worker (constant 2005 US$) in South Africa in 2000 to that in 2003?
Your answer should be very brief. 0.92. What is the ratio of the Agriculture value added per worker (constant 2005 US$) of Caribbean small states in 2001 to that in 2002?
Give a very brief answer. 0.99. What is the ratio of the Agriculture value added per worker (constant 2005 US$) in South Africa in 2001 to that in 2002?
Offer a terse response. 0.92. What is the ratio of the Agriculture value added per worker (constant 2005 US$) of Caribbean small states in 2001 to that in 2003?
Your answer should be very brief. 0.93. What is the ratio of the Agriculture value added per worker (constant 2005 US$) of Djibouti in 2001 to that in 2003?
Offer a terse response. 0.98. What is the ratio of the Agriculture value added per worker (constant 2005 US$) in South Africa in 2001 to that in 2003?
Provide a succinct answer. 0.9. What is the ratio of the Agriculture value added per worker (constant 2005 US$) in Caribbean small states in 2002 to that in 2003?
Provide a succinct answer. 0.95. What is the ratio of the Agriculture value added per worker (constant 2005 US$) in Djibouti in 2002 to that in 2003?
Your response must be concise. 0.99. What is the ratio of the Agriculture value added per worker (constant 2005 US$) in South Africa in 2002 to that in 2003?
Make the answer very short. 0.98. What is the difference between the highest and the second highest Agriculture value added per worker (constant 2005 US$) in Caribbean small states?
Keep it short and to the point. 74.93. What is the difference between the highest and the second highest Agriculture value added per worker (constant 2005 US$) of Djibouti?
Your response must be concise. 2.82. What is the difference between the highest and the second highest Agriculture value added per worker (constant 2005 US$) in South Africa?
Ensure brevity in your answer.  101.65. What is the difference between the highest and the lowest Agriculture value added per worker (constant 2005 US$) in Caribbean small states?
Keep it short and to the point. 484.9. What is the difference between the highest and the lowest Agriculture value added per worker (constant 2005 US$) in Djibouti?
Offer a terse response. 7.74. What is the difference between the highest and the lowest Agriculture value added per worker (constant 2005 US$) of South Africa?
Provide a succinct answer. 844.75. 